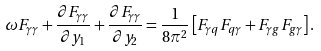<formula> <loc_0><loc_0><loc_500><loc_500>\omega F _ { \gamma \gamma } + \frac { \partial F _ { \gamma \gamma } } { \partial y _ { 1 } } + \frac { \partial F _ { \gamma \gamma } } { \partial y _ { 2 } } = \frac { 1 } { 8 \pi ^ { 2 } } \left [ F _ { \gamma q } F _ { q \gamma } + F _ { \gamma g } F _ { g \gamma } \right ] .</formula> 